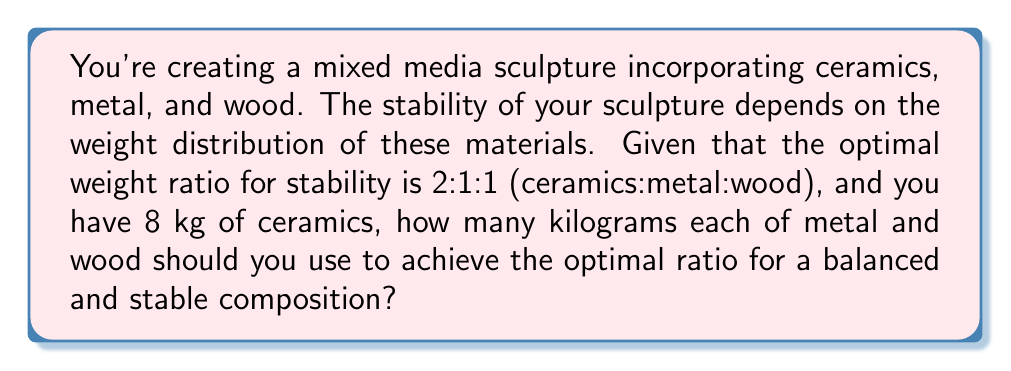Give your solution to this math problem. Let's approach this step-by-step:

1) The given ratio is 2:1:1 for ceramics:metal:wood.

2) We know that we have 8 kg of ceramics, which corresponds to the "2" part of the ratio.

3) Let's define variables:
   $x$ = weight of metal
   $y$ = weight of wood

4) We can set up two equations based on the ratio:

   $$\frac{8}{2} = \frac{x}{1} = \frac{y}{1}$$

5) Simplify:

   $$4 = x = y$$

6) This means that both the metal and wood should each weigh 4 kg to maintain the 2:1:1 ratio with 8 kg of ceramics.

7) To verify:
   Ceramics : Metal : Wood
   8 kg : 4 kg : 4 kg
   
   Which simplifies to 2 : 1 : 1

Therefore, you should use 4 kg each of metal and wood to achieve the optimal ratio for a balanced and stable sculpture composition.
Answer: 4 kg of metal and 4 kg of wood 